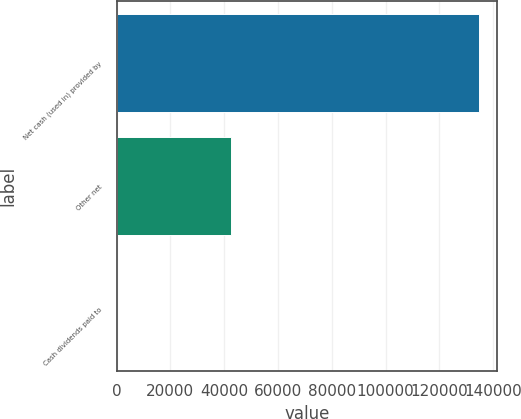Convert chart. <chart><loc_0><loc_0><loc_500><loc_500><bar_chart><fcel>Net cash (used in) provided by<fcel>Other net<fcel>Cash dividends paid to<nl><fcel>134850<fcel>42585<fcel>180<nl></chart> 